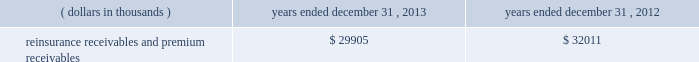In addition , the company has reclassified the following amounts from 201cdistributions from other invested assets 201d included in cash flows from investing activities to 201cdistribution of limited partnership income 201d included in cash flows from operations for interim reporting periods of 2013 : $ 33686 thousand for the three months ended march 31 , 2013 ; $ 9409 thousand and $ 43095 thousand for the three months and six months ended june 30 , 2013 , respectively ; and $ 5638 thousand and $ 48733 thousand for the three months and nine months ended september 30 , 2013 , respectively .
Investments .
Fixed maturity and equity security investments available for sale , at market value , reflect unrealized appreciation and depreciation , as a result of temporary changes in market value during the period , in shareholders 2019 equity , net of income taxes in 201caccumulated other comprehensive income ( loss ) 201d in the consolidated balance sheets .
Fixed maturity and equity securities carried at fair value reflect fair value re- measurements as net realized capital gains and losses in the consolidated statements of operations and comprehensive income ( loss ) .
The company records changes in fair value for its fixed maturities available for sale , at market value through shareholders 2019 equity , net of taxes in accumulated other comprehensive income ( loss ) since cash flows from these investments will be primarily used to settle its reserve for losses and loss adjustment expense liabilities .
The company anticipates holding these investments for an extended period as the cash flow from interest and maturities will fund the projected payout of these liabilities .
Fixed maturities carried at fair value represent a portfolio of convertible bond securities , which have characteristics similar to equity securities and at times , designated foreign denominated fixed maturity securities , which will be used to settle loss and loss adjustment reserves in the same currency .
The company carries all of its equity securities at fair value except for mutual fund investments whose underlying investments are comprised of fixed maturity securities .
For equity securities , available for sale , at fair value , the company reflects changes in value as net realized capital gains and losses since these securities may be sold in the near term depending on financial market conditions .
Interest income on all fixed maturities and dividend income on all equity securities are included as part of net investment income in the consolidated statements of operations and comprehensive income ( loss ) .
Unrealized losses on fixed maturities , which are deemed other-than-temporary and related to the credit quality of a security , are charged to net income ( loss ) as net realized capital losses .
Short-term investments are stated at cost , which approximates market value .
Realized gains or losses on sales of investments are determined on the basis of identified cost .
For non- publicly traded securities , market prices are determined through the use of pricing models that evaluate securities relative to the u.s .
Treasury yield curve , taking into account the issue type , credit quality , and cash flow characteristics of each security .
For publicly traded securities , market value is based on quoted market prices or valuation models that use observable market inputs .
When a sector of the financial markets is inactive or illiquid , the company may use its own assumptions about future cash flows and risk-adjusted discount rates to determine fair value .
Retrospective adjustments are employed to recalculate the values of asset-backed securities .
Each acquisition lot is reviewed to recalculate the effective yield .
The recalculated effective yield is used to derive a book value as if the new yield were applied at the time of acquisition .
Outstanding principal factors from the time of acquisition to the adjustment date are used to calculate the prepayment history for all applicable securities .
Conditional prepayment rates , computed with life to date factor histories and weighted average maturities , are used to effect the calculation of projected and prepayments for pass-through security types .
Other invested assets include limited partnerships , rabbi trusts and an affiliated entity .
Limited partnerships and the affiliated entity are accounted for under the equity method of accounting , which can be recorded on a monthly or quarterly lag .
Uncollectible receivable balances .
The company provides reserves for uncollectible reinsurance recoverable and premium receivable balances based on management 2019s assessment of the collectability of the outstanding balances .
Such reserves are presented in the table below for the periods indicated. .

What is the percentage change in the balance of reinsurance receivables and premium receivables in 2013? 
Computations: ((29905 - 32011) / 32011)
Answer: -0.06579. 